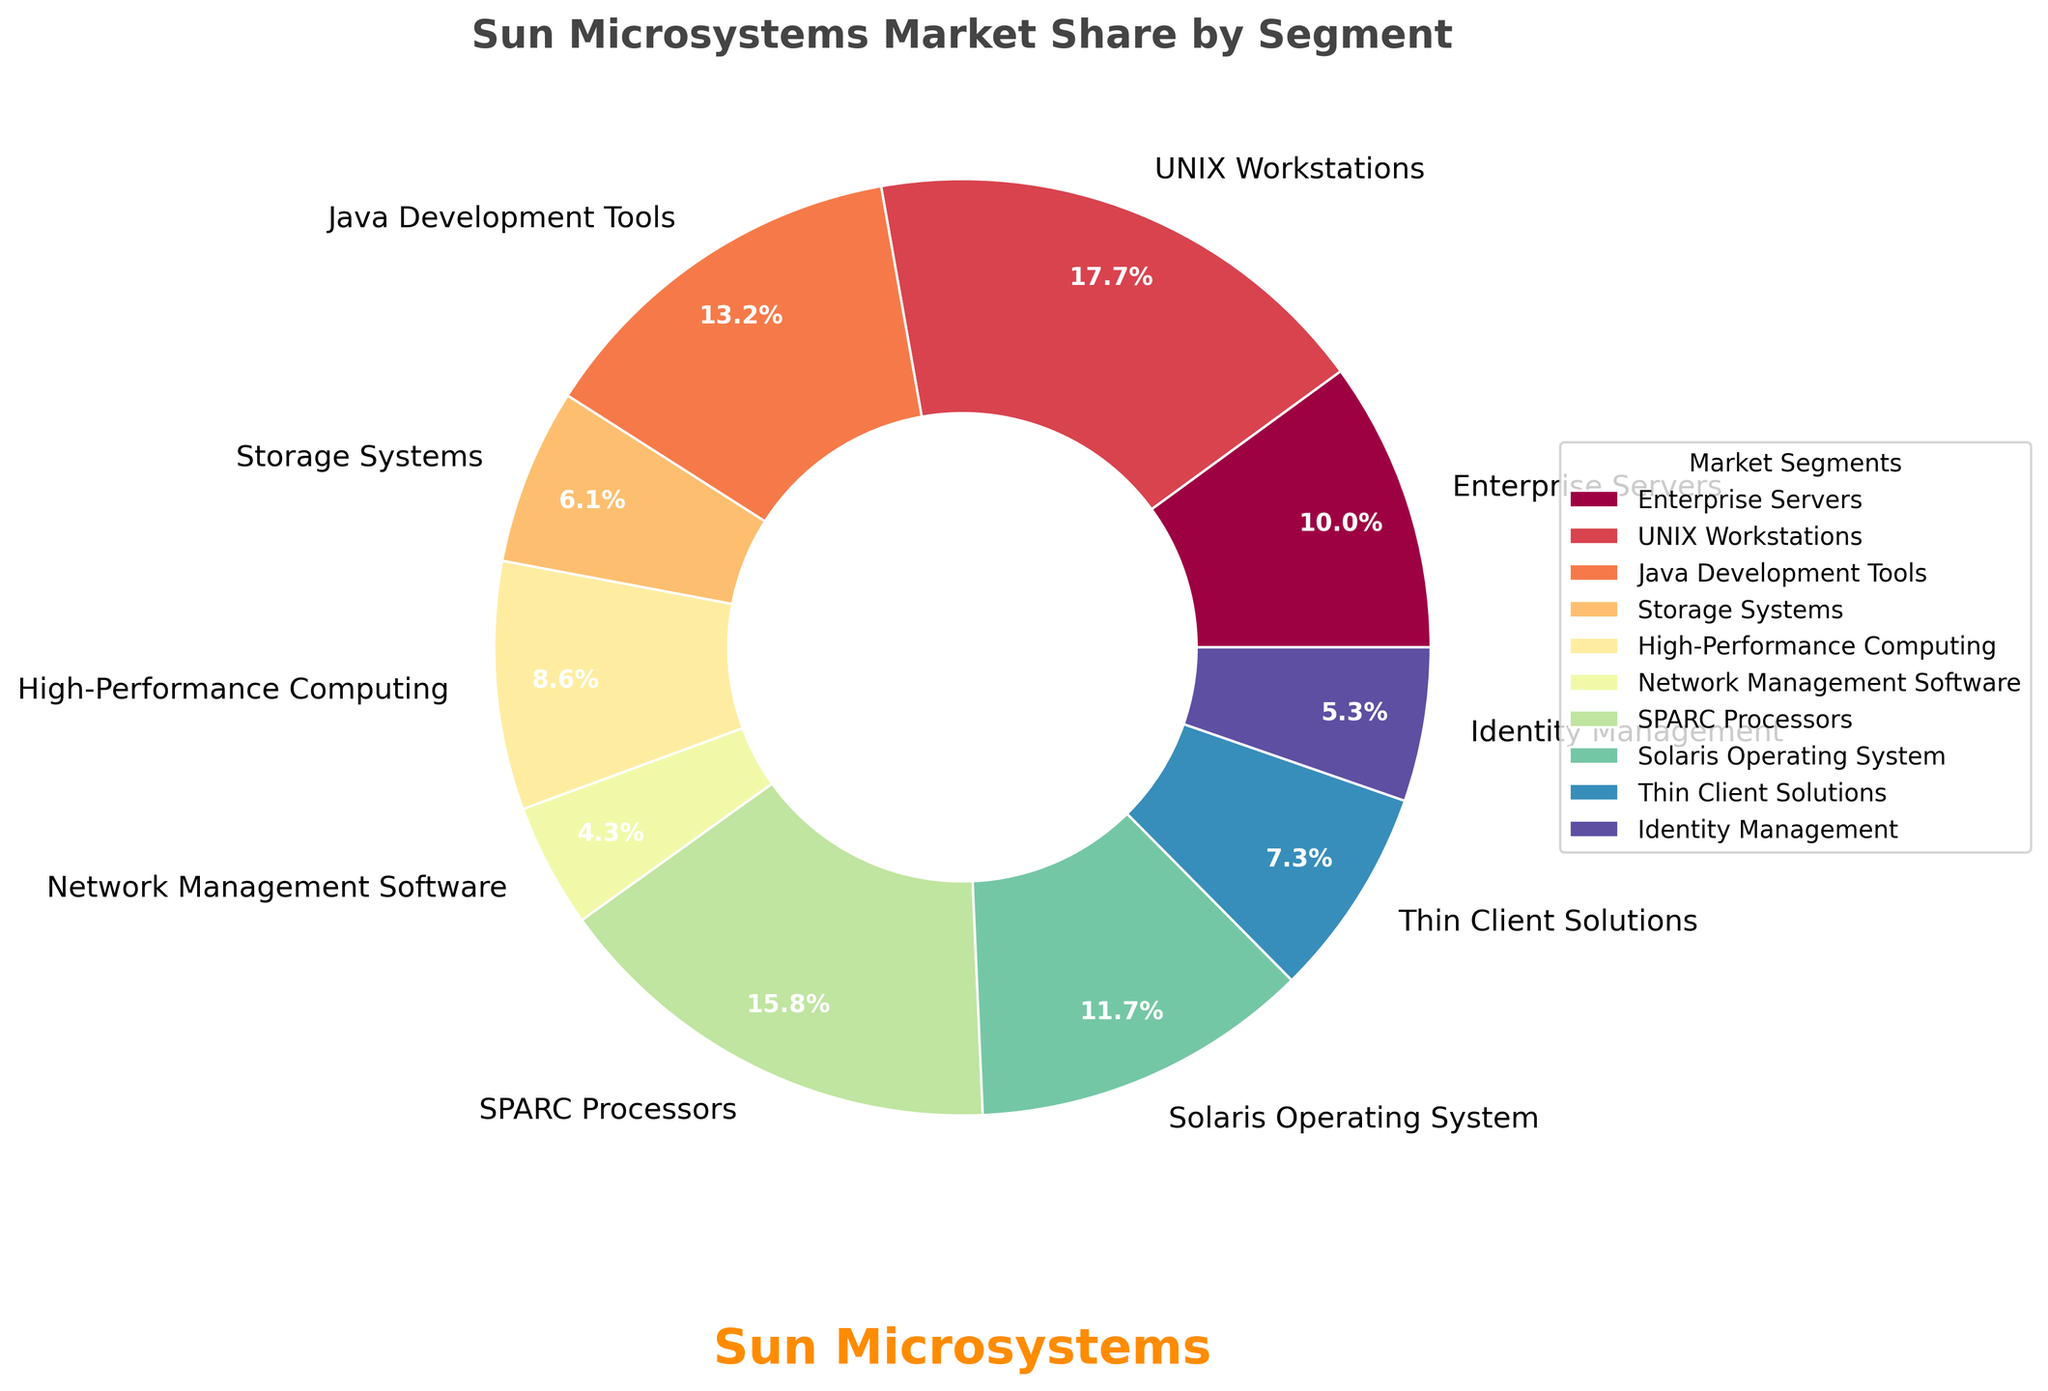What segment has the highest market share? By visually examining the pie chart, the segment with the largest wedge represents the highest market share. This segment is UNIX Workstations.
Answer: UNIX Workstations Which segment has the lowest market share? The segment with the smallest wedge on the pie chart corresponds to the lowest market share. This segment is Network Management Software.
Answer: Network Management Software What is the combined market share of Java Development Tools and Storage Systems? From the pie chart, Java Development Tools has a market share of 24.3%, and Storage Systems has a market share of 11.2%. Their combined share is 24.3% + 11.2% = 35.5%.
Answer: 35.5% How does the market share of SPARC Processors compare to Solaris Operating System? By comparing the sizes of the segments in the pie chart, SPARC Processors (29.1%) have a larger market share than Solaris Operating System (21.6%).
Answer: SPARC Processors have a larger market share Is the market share of Enterprise Servers greater than the combined share of Thin Client Solutions and Identity Management? Enterprise Servers has a market share of 18.5%. Thin Client Solutions and Identity Management together have a combined share of 13.4% + 9.8% = 23.2%. Since 18.5% is less than 23.2%, the market share of Enterprise Servers is not greater.
Answer: No Which segment is represented with the color that is roughly in the middle of the color spectrum on the pie chart? The middle of the color spectrum in the pie chart is associated with a greenish color. This segment is the SPARC Processors.
Answer: SPARC Processors What is the average market share percentage for the segments labeled in the pie chart? To find the average, sum up all the market shares and divide by the number of segments. The sum is 18.5 + 32.7 + 24.3 + 11.2 + 15.8 + 7.9 + 29.1 + 21.6 + 13.4 + 9.8 = 184.3. Dividing by 10 segments, the average is 184.3/10 = 18.43%.
Answer: 18.43% How does the size of the wedge for High-Performance Computing compare visually to that of Identity Management? By visually comparing the wedges on the pie chart, High-Performance Computing has a larger segment than Identity Management.
Answer: High-Performance Computing is larger Which two segments, when combined, have roughly the same market share as UNIX Workstations? UNIX Workstations have a market share of 32.7%. Combining SPARC Processors (29.1%) and Network Management Software (7.9%) gives us 29.1% + 7.9% = 37%, which is slightly higher but close.
Answer: SPARC Processors and Network Management Software 